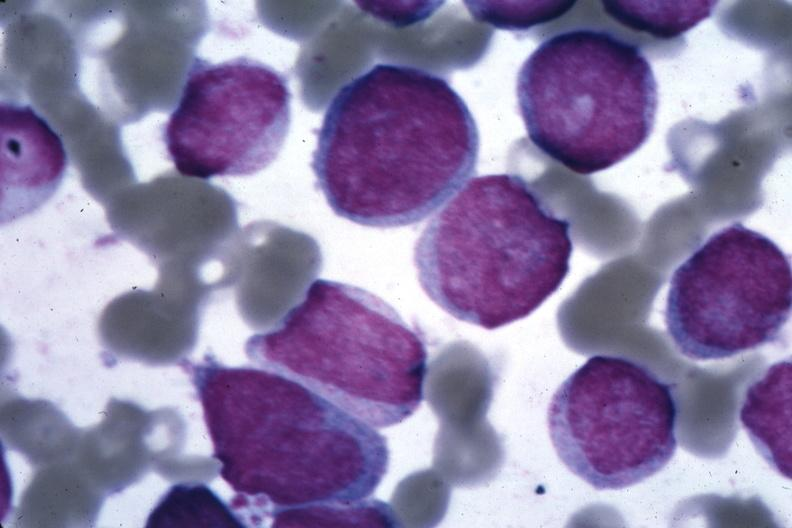s anomalous origin present?
Answer the question using a single word or phrase. No 